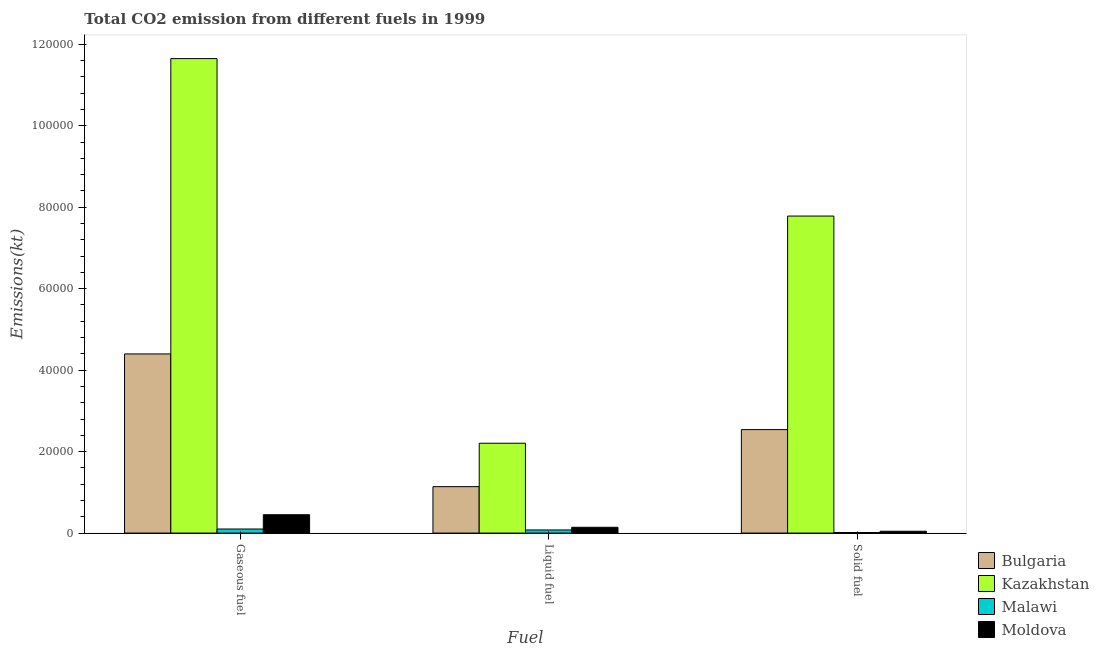How many bars are there on the 1st tick from the left?
Your answer should be compact. 4. What is the label of the 1st group of bars from the left?
Provide a short and direct response. Gaseous fuel. What is the amount of co2 emissions from liquid fuel in Bulgaria?
Make the answer very short. 1.14e+04. Across all countries, what is the maximum amount of co2 emissions from gaseous fuel?
Make the answer very short. 1.16e+05. Across all countries, what is the minimum amount of co2 emissions from solid fuel?
Your answer should be compact. 143.01. In which country was the amount of co2 emissions from gaseous fuel maximum?
Give a very brief answer. Kazakhstan. In which country was the amount of co2 emissions from gaseous fuel minimum?
Make the answer very short. Malawi. What is the total amount of co2 emissions from liquid fuel in the graph?
Give a very brief answer. 3.56e+04. What is the difference between the amount of co2 emissions from solid fuel in Moldova and that in Bulgaria?
Keep it short and to the point. -2.50e+04. What is the difference between the amount of co2 emissions from solid fuel in Moldova and the amount of co2 emissions from gaseous fuel in Bulgaria?
Make the answer very short. -4.35e+04. What is the average amount of co2 emissions from liquid fuel per country?
Offer a very short reply. 8909.89. What is the difference between the amount of co2 emissions from solid fuel and amount of co2 emissions from gaseous fuel in Bulgaria?
Offer a terse response. -1.86e+04. In how many countries, is the amount of co2 emissions from liquid fuel greater than 92000 kt?
Keep it short and to the point. 0. What is the ratio of the amount of co2 emissions from gaseous fuel in Bulgaria to that in Moldova?
Your answer should be very brief. 9.77. Is the difference between the amount of co2 emissions from liquid fuel in Malawi and Bulgaria greater than the difference between the amount of co2 emissions from gaseous fuel in Malawi and Bulgaria?
Offer a terse response. Yes. What is the difference between the highest and the second highest amount of co2 emissions from gaseous fuel?
Ensure brevity in your answer.  7.25e+04. What is the difference between the highest and the lowest amount of co2 emissions from solid fuel?
Provide a short and direct response. 7.77e+04. Is the sum of the amount of co2 emissions from gaseous fuel in Malawi and Moldova greater than the maximum amount of co2 emissions from liquid fuel across all countries?
Your response must be concise. No. What does the 3rd bar from the right in Liquid fuel represents?
Ensure brevity in your answer.  Kazakhstan. Is it the case that in every country, the sum of the amount of co2 emissions from gaseous fuel and amount of co2 emissions from liquid fuel is greater than the amount of co2 emissions from solid fuel?
Provide a short and direct response. Yes. How many bars are there?
Your response must be concise. 12. Are all the bars in the graph horizontal?
Provide a short and direct response. No. How many countries are there in the graph?
Provide a short and direct response. 4. What is the difference between two consecutive major ticks on the Y-axis?
Your response must be concise. 2.00e+04. Does the graph contain any zero values?
Give a very brief answer. No. Where does the legend appear in the graph?
Provide a short and direct response. Bottom right. How many legend labels are there?
Give a very brief answer. 4. What is the title of the graph?
Offer a very short reply. Total CO2 emission from different fuels in 1999. Does "Tunisia" appear as one of the legend labels in the graph?
Your answer should be compact. No. What is the label or title of the X-axis?
Your response must be concise. Fuel. What is the label or title of the Y-axis?
Your answer should be compact. Emissions(kt). What is the Emissions(kt) in Bulgaria in Gaseous fuel?
Ensure brevity in your answer.  4.40e+04. What is the Emissions(kt) in Kazakhstan in Gaseous fuel?
Provide a succinct answer. 1.16e+05. What is the Emissions(kt) of Malawi in Gaseous fuel?
Offer a very short reply. 997.42. What is the Emissions(kt) in Moldova in Gaseous fuel?
Make the answer very short. 4503.08. What is the Emissions(kt) in Bulgaria in Liquid fuel?
Ensure brevity in your answer.  1.14e+04. What is the Emissions(kt) of Kazakhstan in Liquid fuel?
Your response must be concise. 2.21e+04. What is the Emissions(kt) of Malawi in Liquid fuel?
Offer a very short reply. 762.74. What is the Emissions(kt) in Moldova in Liquid fuel?
Offer a very short reply. 1419.13. What is the Emissions(kt) in Bulgaria in Solid fuel?
Ensure brevity in your answer.  2.54e+04. What is the Emissions(kt) in Kazakhstan in Solid fuel?
Provide a short and direct response. 7.78e+04. What is the Emissions(kt) in Malawi in Solid fuel?
Offer a terse response. 143.01. What is the Emissions(kt) of Moldova in Solid fuel?
Make the answer very short. 447.37. Across all Fuel, what is the maximum Emissions(kt) of Bulgaria?
Give a very brief answer. 4.40e+04. Across all Fuel, what is the maximum Emissions(kt) in Kazakhstan?
Your response must be concise. 1.16e+05. Across all Fuel, what is the maximum Emissions(kt) in Malawi?
Make the answer very short. 997.42. Across all Fuel, what is the maximum Emissions(kt) of Moldova?
Offer a terse response. 4503.08. Across all Fuel, what is the minimum Emissions(kt) of Bulgaria?
Keep it short and to the point. 1.14e+04. Across all Fuel, what is the minimum Emissions(kt) in Kazakhstan?
Ensure brevity in your answer.  2.21e+04. Across all Fuel, what is the minimum Emissions(kt) in Malawi?
Give a very brief answer. 143.01. Across all Fuel, what is the minimum Emissions(kt) in Moldova?
Provide a short and direct response. 447.37. What is the total Emissions(kt) in Bulgaria in the graph?
Your answer should be compact. 8.08e+04. What is the total Emissions(kt) in Kazakhstan in the graph?
Give a very brief answer. 2.16e+05. What is the total Emissions(kt) of Malawi in the graph?
Provide a succinct answer. 1903.17. What is the total Emissions(kt) of Moldova in the graph?
Offer a very short reply. 6369.58. What is the difference between the Emissions(kt) in Bulgaria in Gaseous fuel and that in Liquid fuel?
Ensure brevity in your answer.  3.26e+04. What is the difference between the Emissions(kt) in Kazakhstan in Gaseous fuel and that in Liquid fuel?
Your response must be concise. 9.44e+04. What is the difference between the Emissions(kt) of Malawi in Gaseous fuel and that in Liquid fuel?
Give a very brief answer. 234.69. What is the difference between the Emissions(kt) in Moldova in Gaseous fuel and that in Liquid fuel?
Give a very brief answer. 3083.95. What is the difference between the Emissions(kt) in Bulgaria in Gaseous fuel and that in Solid fuel?
Offer a very short reply. 1.86e+04. What is the difference between the Emissions(kt) in Kazakhstan in Gaseous fuel and that in Solid fuel?
Provide a succinct answer. 3.87e+04. What is the difference between the Emissions(kt) of Malawi in Gaseous fuel and that in Solid fuel?
Ensure brevity in your answer.  854.41. What is the difference between the Emissions(kt) of Moldova in Gaseous fuel and that in Solid fuel?
Provide a succinct answer. 4055.7. What is the difference between the Emissions(kt) in Bulgaria in Liquid fuel and that in Solid fuel?
Offer a very short reply. -1.40e+04. What is the difference between the Emissions(kt) in Kazakhstan in Liquid fuel and that in Solid fuel?
Ensure brevity in your answer.  -5.58e+04. What is the difference between the Emissions(kt) in Malawi in Liquid fuel and that in Solid fuel?
Ensure brevity in your answer.  619.72. What is the difference between the Emissions(kt) in Moldova in Liquid fuel and that in Solid fuel?
Offer a very short reply. 971.75. What is the difference between the Emissions(kt) in Bulgaria in Gaseous fuel and the Emissions(kt) in Kazakhstan in Liquid fuel?
Offer a terse response. 2.19e+04. What is the difference between the Emissions(kt) in Bulgaria in Gaseous fuel and the Emissions(kt) in Malawi in Liquid fuel?
Your response must be concise. 4.32e+04. What is the difference between the Emissions(kt) in Bulgaria in Gaseous fuel and the Emissions(kt) in Moldova in Liquid fuel?
Provide a short and direct response. 4.26e+04. What is the difference between the Emissions(kt) in Kazakhstan in Gaseous fuel and the Emissions(kt) in Malawi in Liquid fuel?
Give a very brief answer. 1.16e+05. What is the difference between the Emissions(kt) of Kazakhstan in Gaseous fuel and the Emissions(kt) of Moldova in Liquid fuel?
Make the answer very short. 1.15e+05. What is the difference between the Emissions(kt) in Malawi in Gaseous fuel and the Emissions(kt) in Moldova in Liquid fuel?
Provide a short and direct response. -421.7. What is the difference between the Emissions(kt) of Bulgaria in Gaseous fuel and the Emissions(kt) of Kazakhstan in Solid fuel?
Give a very brief answer. -3.39e+04. What is the difference between the Emissions(kt) of Bulgaria in Gaseous fuel and the Emissions(kt) of Malawi in Solid fuel?
Provide a short and direct response. 4.38e+04. What is the difference between the Emissions(kt) of Bulgaria in Gaseous fuel and the Emissions(kt) of Moldova in Solid fuel?
Your answer should be compact. 4.35e+04. What is the difference between the Emissions(kt) of Kazakhstan in Gaseous fuel and the Emissions(kt) of Malawi in Solid fuel?
Make the answer very short. 1.16e+05. What is the difference between the Emissions(kt) in Kazakhstan in Gaseous fuel and the Emissions(kt) in Moldova in Solid fuel?
Provide a short and direct response. 1.16e+05. What is the difference between the Emissions(kt) in Malawi in Gaseous fuel and the Emissions(kt) in Moldova in Solid fuel?
Keep it short and to the point. 550.05. What is the difference between the Emissions(kt) in Bulgaria in Liquid fuel and the Emissions(kt) in Kazakhstan in Solid fuel?
Offer a terse response. -6.64e+04. What is the difference between the Emissions(kt) in Bulgaria in Liquid fuel and the Emissions(kt) in Malawi in Solid fuel?
Keep it short and to the point. 1.13e+04. What is the difference between the Emissions(kt) in Bulgaria in Liquid fuel and the Emissions(kt) in Moldova in Solid fuel?
Your response must be concise. 1.09e+04. What is the difference between the Emissions(kt) in Kazakhstan in Liquid fuel and the Emissions(kt) in Malawi in Solid fuel?
Provide a short and direct response. 2.19e+04. What is the difference between the Emissions(kt) of Kazakhstan in Liquid fuel and the Emissions(kt) of Moldova in Solid fuel?
Make the answer very short. 2.16e+04. What is the difference between the Emissions(kt) of Malawi in Liquid fuel and the Emissions(kt) of Moldova in Solid fuel?
Your answer should be very brief. 315.36. What is the average Emissions(kt) of Bulgaria per Fuel?
Make the answer very short. 2.69e+04. What is the average Emissions(kt) of Kazakhstan per Fuel?
Offer a very short reply. 7.21e+04. What is the average Emissions(kt) of Malawi per Fuel?
Your answer should be very brief. 634.39. What is the average Emissions(kt) of Moldova per Fuel?
Your answer should be compact. 2123.19. What is the difference between the Emissions(kt) of Bulgaria and Emissions(kt) of Kazakhstan in Gaseous fuel?
Provide a short and direct response. -7.25e+04. What is the difference between the Emissions(kt) in Bulgaria and Emissions(kt) in Malawi in Gaseous fuel?
Your answer should be very brief. 4.30e+04. What is the difference between the Emissions(kt) of Bulgaria and Emissions(kt) of Moldova in Gaseous fuel?
Your response must be concise. 3.95e+04. What is the difference between the Emissions(kt) in Kazakhstan and Emissions(kt) in Malawi in Gaseous fuel?
Keep it short and to the point. 1.15e+05. What is the difference between the Emissions(kt) of Kazakhstan and Emissions(kt) of Moldova in Gaseous fuel?
Offer a very short reply. 1.12e+05. What is the difference between the Emissions(kt) in Malawi and Emissions(kt) in Moldova in Gaseous fuel?
Offer a terse response. -3505.65. What is the difference between the Emissions(kt) of Bulgaria and Emissions(kt) of Kazakhstan in Liquid fuel?
Offer a terse response. -1.07e+04. What is the difference between the Emissions(kt) in Bulgaria and Emissions(kt) in Malawi in Liquid fuel?
Ensure brevity in your answer.  1.06e+04. What is the difference between the Emissions(kt) of Bulgaria and Emissions(kt) of Moldova in Liquid fuel?
Give a very brief answer. 9977.91. What is the difference between the Emissions(kt) of Kazakhstan and Emissions(kt) of Malawi in Liquid fuel?
Your response must be concise. 2.13e+04. What is the difference between the Emissions(kt) in Kazakhstan and Emissions(kt) in Moldova in Liquid fuel?
Your answer should be compact. 2.06e+04. What is the difference between the Emissions(kt) in Malawi and Emissions(kt) in Moldova in Liquid fuel?
Your response must be concise. -656.39. What is the difference between the Emissions(kt) of Bulgaria and Emissions(kt) of Kazakhstan in Solid fuel?
Your response must be concise. -5.24e+04. What is the difference between the Emissions(kt) in Bulgaria and Emissions(kt) in Malawi in Solid fuel?
Your response must be concise. 2.53e+04. What is the difference between the Emissions(kt) of Bulgaria and Emissions(kt) of Moldova in Solid fuel?
Keep it short and to the point. 2.50e+04. What is the difference between the Emissions(kt) of Kazakhstan and Emissions(kt) of Malawi in Solid fuel?
Make the answer very short. 7.77e+04. What is the difference between the Emissions(kt) in Kazakhstan and Emissions(kt) in Moldova in Solid fuel?
Keep it short and to the point. 7.74e+04. What is the difference between the Emissions(kt) in Malawi and Emissions(kt) in Moldova in Solid fuel?
Your answer should be very brief. -304.36. What is the ratio of the Emissions(kt) of Bulgaria in Gaseous fuel to that in Liquid fuel?
Provide a succinct answer. 3.86. What is the ratio of the Emissions(kt) in Kazakhstan in Gaseous fuel to that in Liquid fuel?
Keep it short and to the point. 5.28. What is the ratio of the Emissions(kt) in Malawi in Gaseous fuel to that in Liquid fuel?
Your answer should be very brief. 1.31. What is the ratio of the Emissions(kt) of Moldova in Gaseous fuel to that in Liquid fuel?
Offer a terse response. 3.17. What is the ratio of the Emissions(kt) of Bulgaria in Gaseous fuel to that in Solid fuel?
Your answer should be compact. 1.73. What is the ratio of the Emissions(kt) of Kazakhstan in Gaseous fuel to that in Solid fuel?
Offer a terse response. 1.5. What is the ratio of the Emissions(kt) of Malawi in Gaseous fuel to that in Solid fuel?
Provide a succinct answer. 6.97. What is the ratio of the Emissions(kt) in Moldova in Gaseous fuel to that in Solid fuel?
Provide a short and direct response. 10.07. What is the ratio of the Emissions(kt) in Bulgaria in Liquid fuel to that in Solid fuel?
Your answer should be very brief. 0.45. What is the ratio of the Emissions(kt) in Kazakhstan in Liquid fuel to that in Solid fuel?
Offer a terse response. 0.28. What is the ratio of the Emissions(kt) of Malawi in Liquid fuel to that in Solid fuel?
Offer a very short reply. 5.33. What is the ratio of the Emissions(kt) of Moldova in Liquid fuel to that in Solid fuel?
Your answer should be very brief. 3.17. What is the difference between the highest and the second highest Emissions(kt) in Bulgaria?
Offer a terse response. 1.86e+04. What is the difference between the highest and the second highest Emissions(kt) of Kazakhstan?
Offer a terse response. 3.87e+04. What is the difference between the highest and the second highest Emissions(kt) of Malawi?
Make the answer very short. 234.69. What is the difference between the highest and the second highest Emissions(kt) in Moldova?
Offer a terse response. 3083.95. What is the difference between the highest and the lowest Emissions(kt) in Bulgaria?
Make the answer very short. 3.26e+04. What is the difference between the highest and the lowest Emissions(kt) of Kazakhstan?
Your answer should be compact. 9.44e+04. What is the difference between the highest and the lowest Emissions(kt) in Malawi?
Give a very brief answer. 854.41. What is the difference between the highest and the lowest Emissions(kt) in Moldova?
Your response must be concise. 4055.7. 